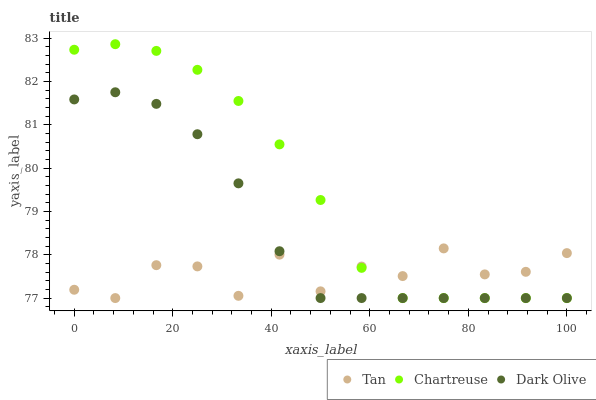Does Tan have the minimum area under the curve?
Answer yes or no. Yes. Does Chartreuse have the maximum area under the curve?
Answer yes or no. Yes. Does Dark Olive have the minimum area under the curve?
Answer yes or no. No. Does Dark Olive have the maximum area under the curve?
Answer yes or no. No. Is Chartreuse the smoothest?
Answer yes or no. Yes. Is Tan the roughest?
Answer yes or no. Yes. Is Dark Olive the smoothest?
Answer yes or no. No. Is Dark Olive the roughest?
Answer yes or no. No. Does Tan have the lowest value?
Answer yes or no. Yes. Does Chartreuse have the highest value?
Answer yes or no. Yes. Does Dark Olive have the highest value?
Answer yes or no. No. Does Tan intersect Dark Olive?
Answer yes or no. Yes. Is Tan less than Dark Olive?
Answer yes or no. No. Is Tan greater than Dark Olive?
Answer yes or no. No. 